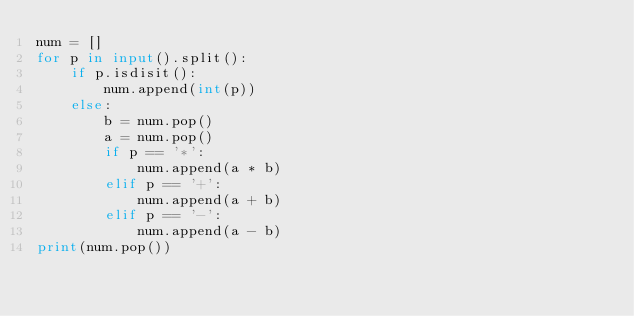<code> <loc_0><loc_0><loc_500><loc_500><_Python_>num = []
for p in input().split():
    if p.isdisit():
        num.append(int(p))
    else:
        b = num.pop()
        a = num.pop()
        if p == '*':
            num.append(a * b)
        elif p == '+':
            num.append(a + b)
        elif p == '-':
            num.append(a - b)
print(num.pop())</code> 